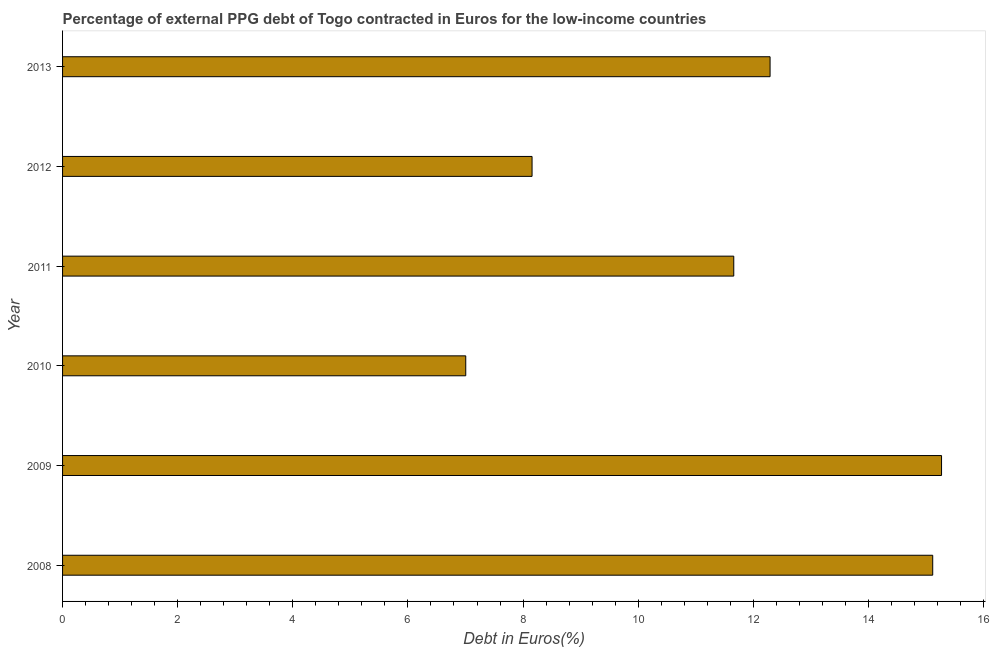Does the graph contain grids?
Ensure brevity in your answer.  No. What is the title of the graph?
Your answer should be very brief. Percentage of external PPG debt of Togo contracted in Euros for the low-income countries. What is the label or title of the X-axis?
Make the answer very short. Debt in Euros(%). What is the currency composition of ppg debt in 2009?
Your response must be concise. 15.27. Across all years, what is the maximum currency composition of ppg debt?
Your response must be concise. 15.27. Across all years, what is the minimum currency composition of ppg debt?
Offer a very short reply. 7. What is the sum of the currency composition of ppg debt?
Provide a succinct answer. 69.5. What is the difference between the currency composition of ppg debt in 2009 and 2013?
Your answer should be very brief. 2.98. What is the average currency composition of ppg debt per year?
Keep it short and to the point. 11.58. What is the median currency composition of ppg debt?
Ensure brevity in your answer.  11.98. Is the difference between the currency composition of ppg debt in 2009 and 2010 greater than the difference between any two years?
Ensure brevity in your answer.  Yes. What is the difference between the highest and the second highest currency composition of ppg debt?
Offer a very short reply. 0.15. What is the difference between the highest and the lowest currency composition of ppg debt?
Keep it short and to the point. 8.27. Are all the bars in the graph horizontal?
Your answer should be very brief. Yes. How many years are there in the graph?
Offer a very short reply. 6. What is the difference between two consecutive major ticks on the X-axis?
Your answer should be compact. 2. What is the Debt in Euros(%) of 2008?
Provide a succinct answer. 15.12. What is the Debt in Euros(%) of 2009?
Give a very brief answer. 15.27. What is the Debt in Euros(%) in 2010?
Provide a short and direct response. 7. What is the Debt in Euros(%) in 2011?
Give a very brief answer. 11.66. What is the Debt in Euros(%) of 2012?
Provide a succinct answer. 8.16. What is the Debt in Euros(%) of 2013?
Give a very brief answer. 12.29. What is the difference between the Debt in Euros(%) in 2008 and 2009?
Offer a terse response. -0.15. What is the difference between the Debt in Euros(%) in 2008 and 2010?
Your answer should be very brief. 8.11. What is the difference between the Debt in Euros(%) in 2008 and 2011?
Offer a very short reply. 3.46. What is the difference between the Debt in Euros(%) in 2008 and 2012?
Ensure brevity in your answer.  6.96. What is the difference between the Debt in Euros(%) in 2008 and 2013?
Provide a short and direct response. 2.83. What is the difference between the Debt in Euros(%) in 2009 and 2010?
Give a very brief answer. 8.27. What is the difference between the Debt in Euros(%) in 2009 and 2011?
Offer a very short reply. 3.61. What is the difference between the Debt in Euros(%) in 2009 and 2012?
Your response must be concise. 7.11. What is the difference between the Debt in Euros(%) in 2009 and 2013?
Your answer should be compact. 2.98. What is the difference between the Debt in Euros(%) in 2010 and 2011?
Keep it short and to the point. -4.66. What is the difference between the Debt in Euros(%) in 2010 and 2012?
Your response must be concise. -1.15. What is the difference between the Debt in Euros(%) in 2010 and 2013?
Give a very brief answer. -5.29. What is the difference between the Debt in Euros(%) in 2011 and 2012?
Give a very brief answer. 3.5. What is the difference between the Debt in Euros(%) in 2011 and 2013?
Your answer should be compact. -0.63. What is the difference between the Debt in Euros(%) in 2012 and 2013?
Offer a terse response. -4.13. What is the ratio of the Debt in Euros(%) in 2008 to that in 2009?
Your answer should be very brief. 0.99. What is the ratio of the Debt in Euros(%) in 2008 to that in 2010?
Give a very brief answer. 2.16. What is the ratio of the Debt in Euros(%) in 2008 to that in 2011?
Ensure brevity in your answer.  1.3. What is the ratio of the Debt in Euros(%) in 2008 to that in 2012?
Offer a very short reply. 1.85. What is the ratio of the Debt in Euros(%) in 2008 to that in 2013?
Make the answer very short. 1.23. What is the ratio of the Debt in Euros(%) in 2009 to that in 2010?
Give a very brief answer. 2.18. What is the ratio of the Debt in Euros(%) in 2009 to that in 2011?
Keep it short and to the point. 1.31. What is the ratio of the Debt in Euros(%) in 2009 to that in 2012?
Provide a short and direct response. 1.87. What is the ratio of the Debt in Euros(%) in 2009 to that in 2013?
Make the answer very short. 1.24. What is the ratio of the Debt in Euros(%) in 2010 to that in 2011?
Your answer should be compact. 0.6. What is the ratio of the Debt in Euros(%) in 2010 to that in 2012?
Your answer should be compact. 0.86. What is the ratio of the Debt in Euros(%) in 2010 to that in 2013?
Your response must be concise. 0.57. What is the ratio of the Debt in Euros(%) in 2011 to that in 2012?
Make the answer very short. 1.43. What is the ratio of the Debt in Euros(%) in 2011 to that in 2013?
Make the answer very short. 0.95. What is the ratio of the Debt in Euros(%) in 2012 to that in 2013?
Make the answer very short. 0.66. 